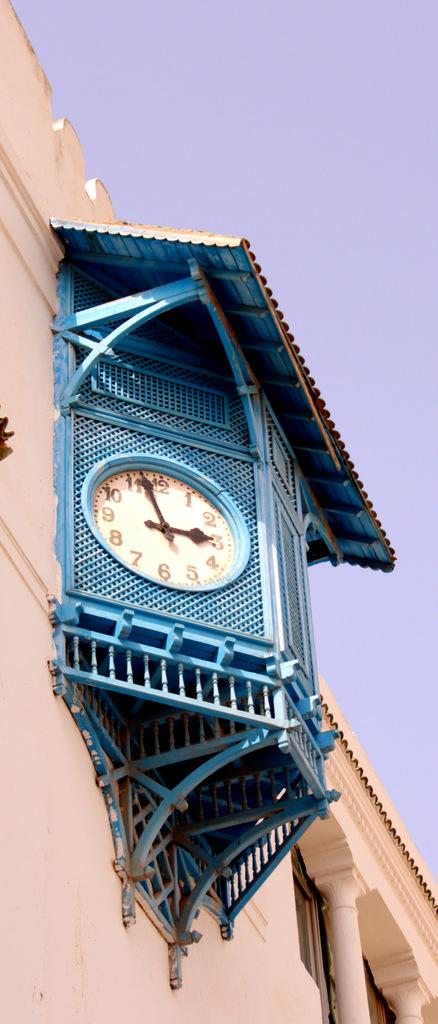<image>
Present a compact description of the photo's key features. The time on a blue clock is very near to 3:00. 